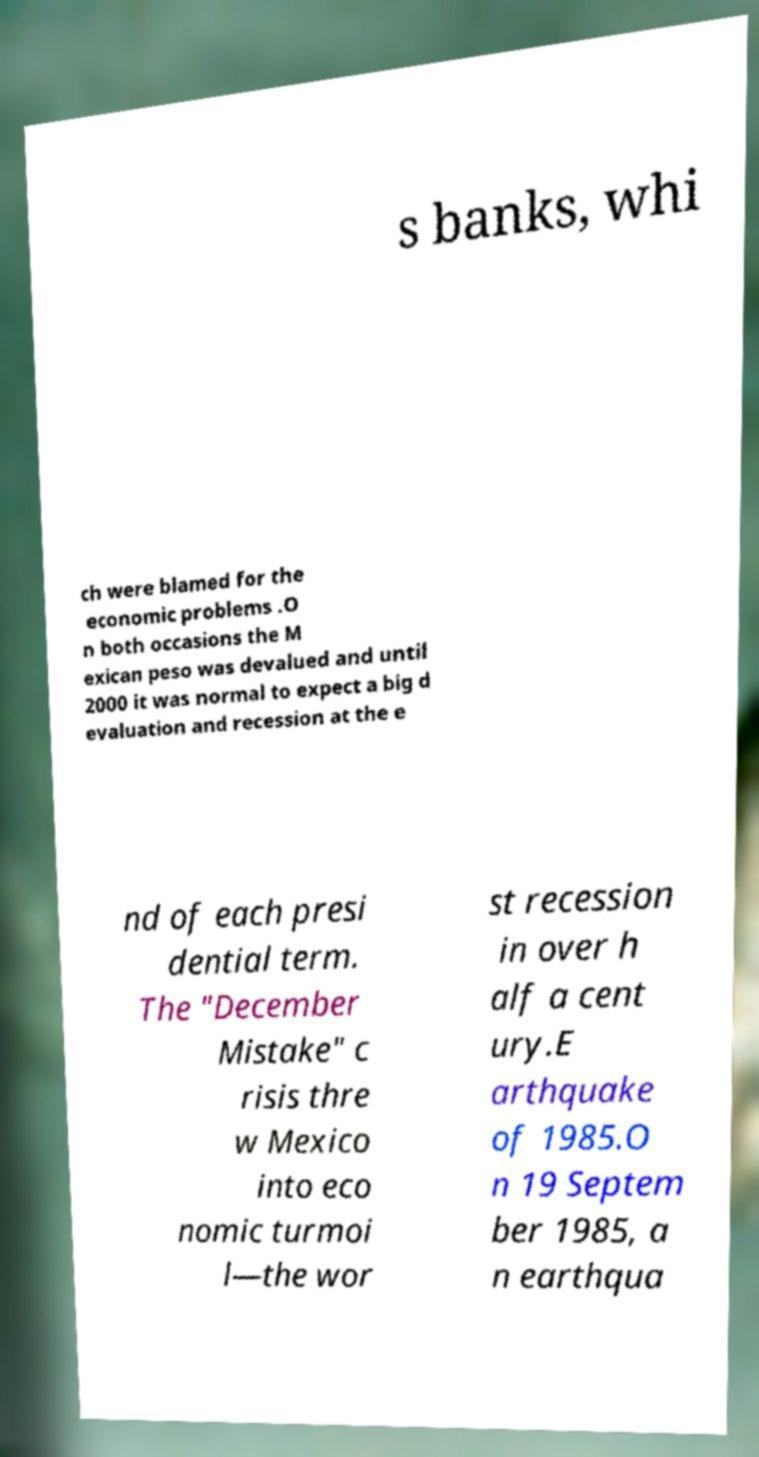What messages or text are displayed in this image? I need them in a readable, typed format. s banks, whi ch were blamed for the economic problems .O n both occasions the M exican peso was devalued and until 2000 it was normal to expect a big d evaluation and recession at the e nd of each presi dential term. The "December Mistake" c risis thre w Mexico into eco nomic turmoi l—the wor st recession in over h alf a cent ury.E arthquake of 1985.O n 19 Septem ber 1985, a n earthqua 